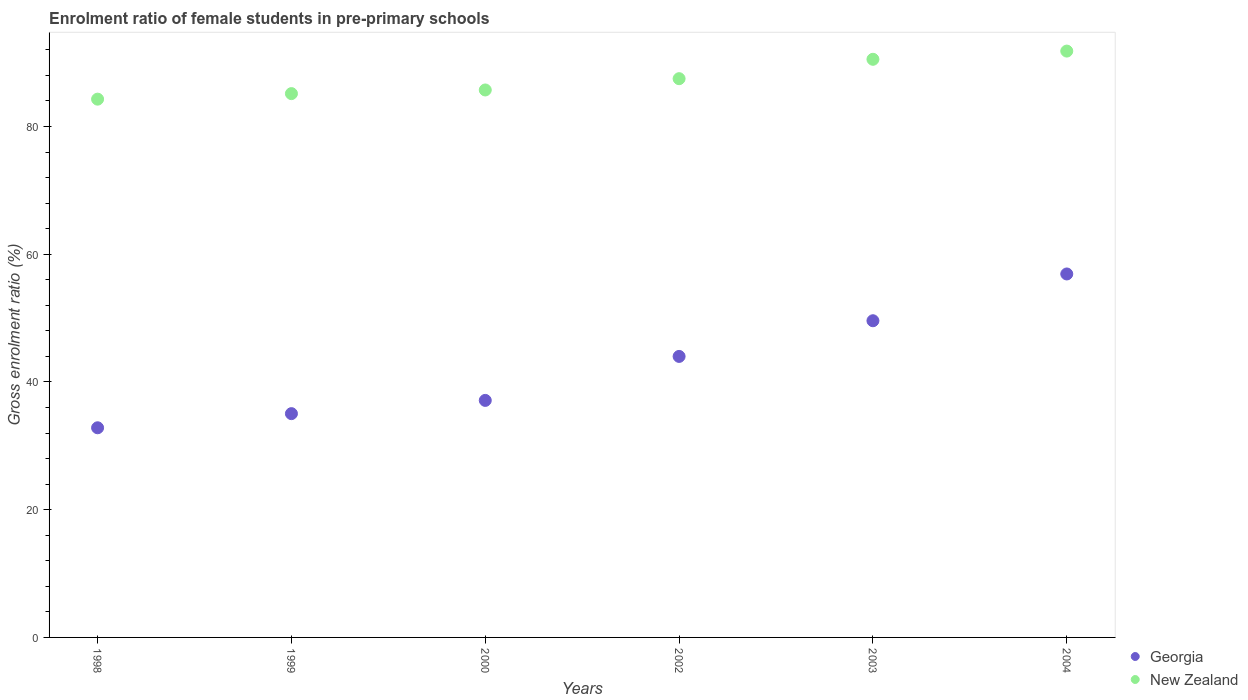Is the number of dotlines equal to the number of legend labels?
Your response must be concise. Yes. What is the enrolment ratio of female students in pre-primary schools in Georgia in 2002?
Offer a very short reply. 44. Across all years, what is the maximum enrolment ratio of female students in pre-primary schools in New Zealand?
Make the answer very short. 91.8. Across all years, what is the minimum enrolment ratio of female students in pre-primary schools in New Zealand?
Make the answer very short. 84.28. What is the total enrolment ratio of female students in pre-primary schools in Georgia in the graph?
Your answer should be very brief. 255.46. What is the difference between the enrolment ratio of female students in pre-primary schools in Georgia in 1998 and that in 2003?
Offer a very short reply. -16.76. What is the difference between the enrolment ratio of female students in pre-primary schools in New Zealand in 2003 and the enrolment ratio of female students in pre-primary schools in Georgia in 1999?
Offer a very short reply. 55.48. What is the average enrolment ratio of female students in pre-primary schools in Georgia per year?
Offer a very short reply. 42.58. In the year 2002, what is the difference between the enrolment ratio of female students in pre-primary schools in Georgia and enrolment ratio of female students in pre-primary schools in New Zealand?
Offer a terse response. -43.49. In how many years, is the enrolment ratio of female students in pre-primary schools in Georgia greater than 60 %?
Provide a succinct answer. 0. What is the ratio of the enrolment ratio of female students in pre-primary schools in New Zealand in 2000 to that in 2003?
Offer a very short reply. 0.95. Is the difference between the enrolment ratio of female students in pre-primary schools in Georgia in 2000 and 2002 greater than the difference between the enrolment ratio of female students in pre-primary schools in New Zealand in 2000 and 2002?
Make the answer very short. No. What is the difference between the highest and the second highest enrolment ratio of female students in pre-primary schools in New Zealand?
Make the answer very short. 1.29. What is the difference between the highest and the lowest enrolment ratio of female students in pre-primary schools in Georgia?
Offer a very short reply. 24.08. Is the enrolment ratio of female students in pre-primary schools in Georgia strictly less than the enrolment ratio of female students in pre-primary schools in New Zealand over the years?
Give a very brief answer. Yes. What is the difference between two consecutive major ticks on the Y-axis?
Your answer should be compact. 20. Are the values on the major ticks of Y-axis written in scientific E-notation?
Offer a very short reply. No. Does the graph contain any zero values?
Give a very brief answer. No. Does the graph contain grids?
Offer a very short reply. No. How many legend labels are there?
Make the answer very short. 2. How are the legend labels stacked?
Make the answer very short. Vertical. What is the title of the graph?
Ensure brevity in your answer.  Enrolment ratio of female students in pre-primary schools. What is the label or title of the X-axis?
Give a very brief answer. Years. What is the label or title of the Y-axis?
Offer a very short reply. Gross enrolment ratio (%). What is the Gross enrolment ratio (%) in Georgia in 1998?
Your answer should be compact. 32.82. What is the Gross enrolment ratio (%) in New Zealand in 1998?
Provide a short and direct response. 84.28. What is the Gross enrolment ratio (%) of Georgia in 1999?
Your response must be concise. 35.04. What is the Gross enrolment ratio (%) in New Zealand in 1999?
Offer a very short reply. 85.14. What is the Gross enrolment ratio (%) of Georgia in 2000?
Offer a terse response. 37.11. What is the Gross enrolment ratio (%) of New Zealand in 2000?
Offer a very short reply. 85.72. What is the Gross enrolment ratio (%) of Georgia in 2002?
Your answer should be compact. 44. What is the Gross enrolment ratio (%) of New Zealand in 2002?
Your answer should be compact. 87.48. What is the Gross enrolment ratio (%) in Georgia in 2003?
Keep it short and to the point. 49.58. What is the Gross enrolment ratio (%) in New Zealand in 2003?
Your response must be concise. 90.52. What is the Gross enrolment ratio (%) of Georgia in 2004?
Your answer should be compact. 56.91. What is the Gross enrolment ratio (%) in New Zealand in 2004?
Keep it short and to the point. 91.8. Across all years, what is the maximum Gross enrolment ratio (%) of Georgia?
Provide a short and direct response. 56.91. Across all years, what is the maximum Gross enrolment ratio (%) of New Zealand?
Give a very brief answer. 91.8. Across all years, what is the minimum Gross enrolment ratio (%) in Georgia?
Ensure brevity in your answer.  32.82. Across all years, what is the minimum Gross enrolment ratio (%) of New Zealand?
Provide a short and direct response. 84.28. What is the total Gross enrolment ratio (%) of Georgia in the graph?
Give a very brief answer. 255.46. What is the total Gross enrolment ratio (%) of New Zealand in the graph?
Ensure brevity in your answer.  524.94. What is the difference between the Gross enrolment ratio (%) in Georgia in 1998 and that in 1999?
Your response must be concise. -2.21. What is the difference between the Gross enrolment ratio (%) in New Zealand in 1998 and that in 1999?
Provide a succinct answer. -0.87. What is the difference between the Gross enrolment ratio (%) of Georgia in 1998 and that in 2000?
Keep it short and to the point. -4.29. What is the difference between the Gross enrolment ratio (%) of New Zealand in 1998 and that in 2000?
Ensure brevity in your answer.  -1.44. What is the difference between the Gross enrolment ratio (%) of Georgia in 1998 and that in 2002?
Ensure brevity in your answer.  -11.17. What is the difference between the Gross enrolment ratio (%) of New Zealand in 1998 and that in 2002?
Ensure brevity in your answer.  -3.21. What is the difference between the Gross enrolment ratio (%) of Georgia in 1998 and that in 2003?
Your answer should be very brief. -16.76. What is the difference between the Gross enrolment ratio (%) of New Zealand in 1998 and that in 2003?
Offer a terse response. -6.24. What is the difference between the Gross enrolment ratio (%) of Georgia in 1998 and that in 2004?
Offer a terse response. -24.08. What is the difference between the Gross enrolment ratio (%) of New Zealand in 1998 and that in 2004?
Provide a succinct answer. -7.53. What is the difference between the Gross enrolment ratio (%) of Georgia in 1999 and that in 2000?
Your answer should be very brief. -2.07. What is the difference between the Gross enrolment ratio (%) in New Zealand in 1999 and that in 2000?
Offer a terse response. -0.57. What is the difference between the Gross enrolment ratio (%) of Georgia in 1999 and that in 2002?
Your answer should be very brief. -8.96. What is the difference between the Gross enrolment ratio (%) of New Zealand in 1999 and that in 2002?
Your response must be concise. -2.34. What is the difference between the Gross enrolment ratio (%) in Georgia in 1999 and that in 2003?
Provide a succinct answer. -14.55. What is the difference between the Gross enrolment ratio (%) in New Zealand in 1999 and that in 2003?
Keep it short and to the point. -5.37. What is the difference between the Gross enrolment ratio (%) of Georgia in 1999 and that in 2004?
Give a very brief answer. -21.87. What is the difference between the Gross enrolment ratio (%) of New Zealand in 1999 and that in 2004?
Make the answer very short. -6.66. What is the difference between the Gross enrolment ratio (%) of Georgia in 2000 and that in 2002?
Provide a succinct answer. -6.89. What is the difference between the Gross enrolment ratio (%) of New Zealand in 2000 and that in 2002?
Offer a terse response. -1.77. What is the difference between the Gross enrolment ratio (%) of Georgia in 2000 and that in 2003?
Your answer should be very brief. -12.47. What is the difference between the Gross enrolment ratio (%) in New Zealand in 2000 and that in 2003?
Give a very brief answer. -4.8. What is the difference between the Gross enrolment ratio (%) of Georgia in 2000 and that in 2004?
Your answer should be compact. -19.8. What is the difference between the Gross enrolment ratio (%) of New Zealand in 2000 and that in 2004?
Your answer should be very brief. -6.09. What is the difference between the Gross enrolment ratio (%) in Georgia in 2002 and that in 2003?
Offer a terse response. -5.59. What is the difference between the Gross enrolment ratio (%) in New Zealand in 2002 and that in 2003?
Give a very brief answer. -3.03. What is the difference between the Gross enrolment ratio (%) in Georgia in 2002 and that in 2004?
Provide a short and direct response. -12.91. What is the difference between the Gross enrolment ratio (%) in New Zealand in 2002 and that in 2004?
Keep it short and to the point. -4.32. What is the difference between the Gross enrolment ratio (%) in Georgia in 2003 and that in 2004?
Your response must be concise. -7.32. What is the difference between the Gross enrolment ratio (%) of New Zealand in 2003 and that in 2004?
Provide a short and direct response. -1.29. What is the difference between the Gross enrolment ratio (%) of Georgia in 1998 and the Gross enrolment ratio (%) of New Zealand in 1999?
Make the answer very short. -52.32. What is the difference between the Gross enrolment ratio (%) of Georgia in 1998 and the Gross enrolment ratio (%) of New Zealand in 2000?
Offer a very short reply. -52.89. What is the difference between the Gross enrolment ratio (%) of Georgia in 1998 and the Gross enrolment ratio (%) of New Zealand in 2002?
Offer a very short reply. -54.66. What is the difference between the Gross enrolment ratio (%) of Georgia in 1998 and the Gross enrolment ratio (%) of New Zealand in 2003?
Provide a short and direct response. -57.69. What is the difference between the Gross enrolment ratio (%) in Georgia in 1998 and the Gross enrolment ratio (%) in New Zealand in 2004?
Your answer should be compact. -58.98. What is the difference between the Gross enrolment ratio (%) of Georgia in 1999 and the Gross enrolment ratio (%) of New Zealand in 2000?
Give a very brief answer. -50.68. What is the difference between the Gross enrolment ratio (%) of Georgia in 1999 and the Gross enrolment ratio (%) of New Zealand in 2002?
Keep it short and to the point. -52.45. What is the difference between the Gross enrolment ratio (%) in Georgia in 1999 and the Gross enrolment ratio (%) in New Zealand in 2003?
Your answer should be compact. -55.48. What is the difference between the Gross enrolment ratio (%) of Georgia in 1999 and the Gross enrolment ratio (%) of New Zealand in 2004?
Offer a very short reply. -56.77. What is the difference between the Gross enrolment ratio (%) in Georgia in 2000 and the Gross enrolment ratio (%) in New Zealand in 2002?
Keep it short and to the point. -50.37. What is the difference between the Gross enrolment ratio (%) of Georgia in 2000 and the Gross enrolment ratio (%) of New Zealand in 2003?
Provide a succinct answer. -53.41. What is the difference between the Gross enrolment ratio (%) in Georgia in 2000 and the Gross enrolment ratio (%) in New Zealand in 2004?
Offer a very short reply. -54.69. What is the difference between the Gross enrolment ratio (%) in Georgia in 2002 and the Gross enrolment ratio (%) in New Zealand in 2003?
Your response must be concise. -46.52. What is the difference between the Gross enrolment ratio (%) of Georgia in 2002 and the Gross enrolment ratio (%) of New Zealand in 2004?
Keep it short and to the point. -47.81. What is the difference between the Gross enrolment ratio (%) in Georgia in 2003 and the Gross enrolment ratio (%) in New Zealand in 2004?
Make the answer very short. -42.22. What is the average Gross enrolment ratio (%) in Georgia per year?
Offer a terse response. 42.58. What is the average Gross enrolment ratio (%) in New Zealand per year?
Ensure brevity in your answer.  87.49. In the year 1998, what is the difference between the Gross enrolment ratio (%) of Georgia and Gross enrolment ratio (%) of New Zealand?
Provide a short and direct response. -51.45. In the year 1999, what is the difference between the Gross enrolment ratio (%) in Georgia and Gross enrolment ratio (%) in New Zealand?
Make the answer very short. -50.11. In the year 2000, what is the difference between the Gross enrolment ratio (%) in Georgia and Gross enrolment ratio (%) in New Zealand?
Give a very brief answer. -48.6. In the year 2002, what is the difference between the Gross enrolment ratio (%) of Georgia and Gross enrolment ratio (%) of New Zealand?
Give a very brief answer. -43.49. In the year 2003, what is the difference between the Gross enrolment ratio (%) in Georgia and Gross enrolment ratio (%) in New Zealand?
Keep it short and to the point. -40.93. In the year 2004, what is the difference between the Gross enrolment ratio (%) in Georgia and Gross enrolment ratio (%) in New Zealand?
Offer a terse response. -34.9. What is the ratio of the Gross enrolment ratio (%) in Georgia in 1998 to that in 1999?
Give a very brief answer. 0.94. What is the ratio of the Gross enrolment ratio (%) of New Zealand in 1998 to that in 1999?
Provide a short and direct response. 0.99. What is the ratio of the Gross enrolment ratio (%) of Georgia in 1998 to that in 2000?
Provide a short and direct response. 0.88. What is the ratio of the Gross enrolment ratio (%) in New Zealand in 1998 to that in 2000?
Keep it short and to the point. 0.98. What is the ratio of the Gross enrolment ratio (%) in Georgia in 1998 to that in 2002?
Ensure brevity in your answer.  0.75. What is the ratio of the Gross enrolment ratio (%) of New Zealand in 1998 to that in 2002?
Your answer should be very brief. 0.96. What is the ratio of the Gross enrolment ratio (%) in Georgia in 1998 to that in 2003?
Offer a terse response. 0.66. What is the ratio of the Gross enrolment ratio (%) of New Zealand in 1998 to that in 2003?
Your answer should be compact. 0.93. What is the ratio of the Gross enrolment ratio (%) in Georgia in 1998 to that in 2004?
Ensure brevity in your answer.  0.58. What is the ratio of the Gross enrolment ratio (%) of New Zealand in 1998 to that in 2004?
Offer a terse response. 0.92. What is the ratio of the Gross enrolment ratio (%) in Georgia in 1999 to that in 2000?
Keep it short and to the point. 0.94. What is the ratio of the Gross enrolment ratio (%) of New Zealand in 1999 to that in 2000?
Make the answer very short. 0.99. What is the ratio of the Gross enrolment ratio (%) in Georgia in 1999 to that in 2002?
Make the answer very short. 0.8. What is the ratio of the Gross enrolment ratio (%) in New Zealand in 1999 to that in 2002?
Your response must be concise. 0.97. What is the ratio of the Gross enrolment ratio (%) in Georgia in 1999 to that in 2003?
Give a very brief answer. 0.71. What is the ratio of the Gross enrolment ratio (%) in New Zealand in 1999 to that in 2003?
Your response must be concise. 0.94. What is the ratio of the Gross enrolment ratio (%) in Georgia in 1999 to that in 2004?
Your answer should be compact. 0.62. What is the ratio of the Gross enrolment ratio (%) of New Zealand in 1999 to that in 2004?
Provide a short and direct response. 0.93. What is the ratio of the Gross enrolment ratio (%) of Georgia in 2000 to that in 2002?
Your answer should be compact. 0.84. What is the ratio of the Gross enrolment ratio (%) of New Zealand in 2000 to that in 2002?
Provide a succinct answer. 0.98. What is the ratio of the Gross enrolment ratio (%) in Georgia in 2000 to that in 2003?
Your response must be concise. 0.75. What is the ratio of the Gross enrolment ratio (%) in New Zealand in 2000 to that in 2003?
Make the answer very short. 0.95. What is the ratio of the Gross enrolment ratio (%) in Georgia in 2000 to that in 2004?
Make the answer very short. 0.65. What is the ratio of the Gross enrolment ratio (%) of New Zealand in 2000 to that in 2004?
Keep it short and to the point. 0.93. What is the ratio of the Gross enrolment ratio (%) in Georgia in 2002 to that in 2003?
Your answer should be very brief. 0.89. What is the ratio of the Gross enrolment ratio (%) in New Zealand in 2002 to that in 2003?
Offer a very short reply. 0.97. What is the ratio of the Gross enrolment ratio (%) in Georgia in 2002 to that in 2004?
Your answer should be compact. 0.77. What is the ratio of the Gross enrolment ratio (%) in New Zealand in 2002 to that in 2004?
Give a very brief answer. 0.95. What is the ratio of the Gross enrolment ratio (%) of Georgia in 2003 to that in 2004?
Your answer should be very brief. 0.87. What is the ratio of the Gross enrolment ratio (%) of New Zealand in 2003 to that in 2004?
Ensure brevity in your answer.  0.99. What is the difference between the highest and the second highest Gross enrolment ratio (%) of Georgia?
Your response must be concise. 7.32. What is the difference between the highest and the second highest Gross enrolment ratio (%) in New Zealand?
Your response must be concise. 1.29. What is the difference between the highest and the lowest Gross enrolment ratio (%) in Georgia?
Ensure brevity in your answer.  24.08. What is the difference between the highest and the lowest Gross enrolment ratio (%) of New Zealand?
Your answer should be very brief. 7.53. 